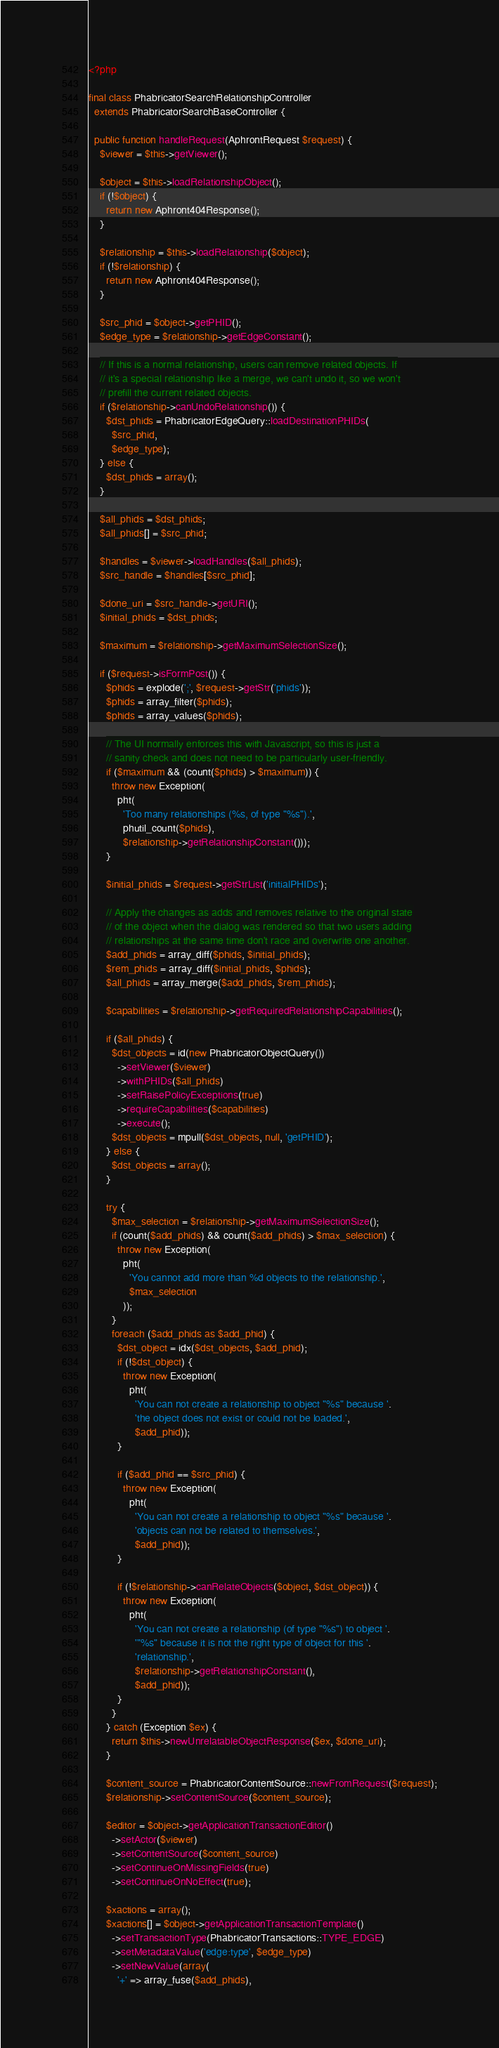Convert code to text. <code><loc_0><loc_0><loc_500><loc_500><_PHP_><?php

final class PhabricatorSearchRelationshipController
  extends PhabricatorSearchBaseController {

  public function handleRequest(AphrontRequest $request) {
    $viewer = $this->getViewer();

    $object = $this->loadRelationshipObject();
    if (!$object) {
      return new Aphront404Response();
    }

    $relationship = $this->loadRelationship($object);
    if (!$relationship) {
      return new Aphront404Response();
    }

    $src_phid = $object->getPHID();
    $edge_type = $relationship->getEdgeConstant();

    // If this is a normal relationship, users can remove related objects. If
    // it's a special relationship like a merge, we can't undo it, so we won't
    // prefill the current related objects.
    if ($relationship->canUndoRelationship()) {
      $dst_phids = PhabricatorEdgeQuery::loadDestinationPHIDs(
        $src_phid,
        $edge_type);
    } else {
      $dst_phids = array();
    }

    $all_phids = $dst_phids;
    $all_phids[] = $src_phid;

    $handles = $viewer->loadHandles($all_phids);
    $src_handle = $handles[$src_phid];

    $done_uri = $src_handle->getURI();
    $initial_phids = $dst_phids;

    $maximum = $relationship->getMaximumSelectionSize();

    if ($request->isFormPost()) {
      $phids = explode(';', $request->getStr('phids'));
      $phids = array_filter($phids);
      $phids = array_values($phids);

      // The UI normally enforces this with Javascript, so this is just a
      // sanity check and does not need to be particularly user-friendly.
      if ($maximum && (count($phids) > $maximum)) {
        throw new Exception(
          pht(
            'Too many relationships (%s, of type "%s").',
            phutil_count($phids),
            $relationship->getRelationshipConstant()));
      }

      $initial_phids = $request->getStrList('initialPHIDs');

      // Apply the changes as adds and removes relative to the original state
      // of the object when the dialog was rendered so that two users adding
      // relationships at the same time don't race and overwrite one another.
      $add_phids = array_diff($phids, $initial_phids);
      $rem_phids = array_diff($initial_phids, $phids);
      $all_phids = array_merge($add_phids, $rem_phids);

      $capabilities = $relationship->getRequiredRelationshipCapabilities();

      if ($all_phids) {
        $dst_objects = id(new PhabricatorObjectQuery())
          ->setViewer($viewer)
          ->withPHIDs($all_phids)
          ->setRaisePolicyExceptions(true)
          ->requireCapabilities($capabilities)
          ->execute();
        $dst_objects = mpull($dst_objects, null, 'getPHID');
      } else {
        $dst_objects = array();
      }

      try {
        $max_selection = $relationship->getMaximumSelectionSize();
        if (count($add_phids) && count($add_phids) > $max_selection) {
          throw new Exception(
            pht(
              'You cannot add more than %d objects to the relationship.',
              $max_selection
            ));
        }
        foreach ($add_phids as $add_phid) {
          $dst_object = idx($dst_objects, $add_phid);
          if (!$dst_object) {
            throw new Exception(
              pht(
                'You can not create a relationship to object "%s" because '.
                'the object does not exist or could not be loaded.',
                $add_phid));
          }

          if ($add_phid == $src_phid) {
            throw new Exception(
              pht(
                'You can not create a relationship to object "%s" because '.
                'objects can not be related to themselves.',
                $add_phid));
          }

          if (!$relationship->canRelateObjects($object, $dst_object)) {
            throw new Exception(
              pht(
                'You can not create a relationship (of type "%s") to object '.
                '"%s" because it is not the right type of object for this '.
                'relationship.',
                $relationship->getRelationshipConstant(),
                $add_phid));
          }
        }
      } catch (Exception $ex) {
        return $this->newUnrelatableObjectResponse($ex, $done_uri);
      }

      $content_source = PhabricatorContentSource::newFromRequest($request);
      $relationship->setContentSource($content_source);

      $editor = $object->getApplicationTransactionEditor()
        ->setActor($viewer)
        ->setContentSource($content_source)
        ->setContinueOnMissingFields(true)
        ->setContinueOnNoEffect(true);

      $xactions = array();
      $xactions[] = $object->getApplicationTransactionTemplate()
        ->setTransactionType(PhabricatorTransactions::TYPE_EDGE)
        ->setMetadataValue('edge:type', $edge_type)
        ->setNewValue(array(
          '+' => array_fuse($add_phids),</code> 